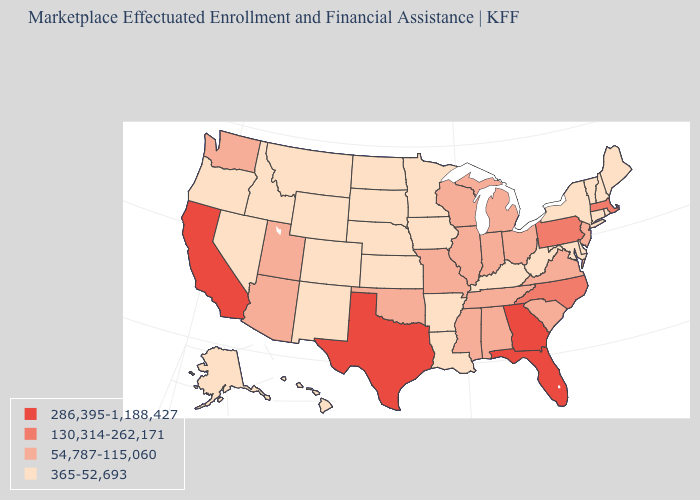What is the lowest value in states that border Delaware?
Write a very short answer. 365-52,693. Name the states that have a value in the range 365-52,693?
Answer briefly. Alaska, Arkansas, Colorado, Connecticut, Delaware, Hawaii, Idaho, Iowa, Kansas, Kentucky, Louisiana, Maine, Maryland, Minnesota, Montana, Nebraska, Nevada, New Hampshire, New Mexico, New York, North Dakota, Oregon, Rhode Island, South Dakota, Vermont, West Virginia, Wyoming. Which states hav the highest value in the West?
Keep it brief. California. Does Missouri have the same value as Tennessee?
Concise answer only. Yes. Which states hav the highest value in the MidWest?
Write a very short answer. Illinois, Indiana, Michigan, Missouri, Ohio, Wisconsin. Does Colorado have the lowest value in the USA?
Give a very brief answer. Yes. Does Kansas have the highest value in the MidWest?
Concise answer only. No. Name the states that have a value in the range 54,787-115,060?
Short answer required. Alabama, Arizona, Illinois, Indiana, Michigan, Mississippi, Missouri, New Jersey, Ohio, Oklahoma, South Carolina, Tennessee, Utah, Virginia, Washington, Wisconsin. Name the states that have a value in the range 365-52,693?
Concise answer only. Alaska, Arkansas, Colorado, Connecticut, Delaware, Hawaii, Idaho, Iowa, Kansas, Kentucky, Louisiana, Maine, Maryland, Minnesota, Montana, Nebraska, Nevada, New Hampshire, New Mexico, New York, North Dakota, Oregon, Rhode Island, South Dakota, Vermont, West Virginia, Wyoming. Which states have the highest value in the USA?
Write a very short answer. California, Florida, Georgia, Texas. What is the lowest value in the USA?
Write a very short answer. 365-52,693. What is the lowest value in the Northeast?
Keep it brief. 365-52,693. Does Colorado have the same value as Wyoming?
Answer briefly. Yes. Is the legend a continuous bar?
Answer briefly. No. What is the lowest value in the South?
Quick response, please. 365-52,693. 